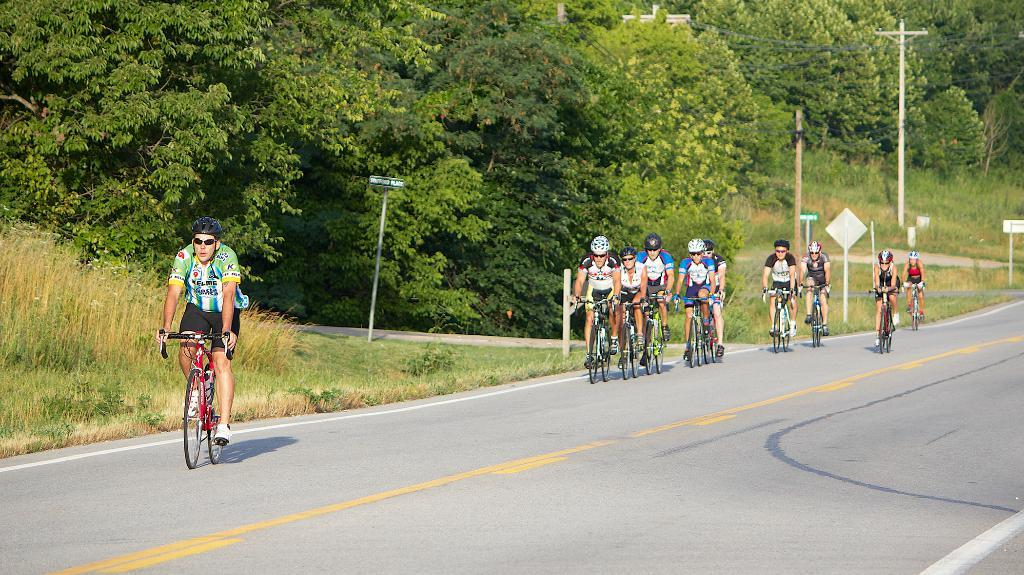What are the people in the image doing? The people in the image are riding bicycles on the road. What can be seen in the background of the image? In the background, there are electric poles, electric cables, trees, name boards, and sign boards. Can you describe the electric poles and cables in the background? Yes, there are electric poles and cables in the background, which are typically used for transmitting electricity. What type of soap is being used to clean the shirts hanging on the name boards in the image? There are no shirts or soap present in the image; it features people riding bicycles and background elements such as electric poles, electric cables, trees, name boards, and sign boards. 